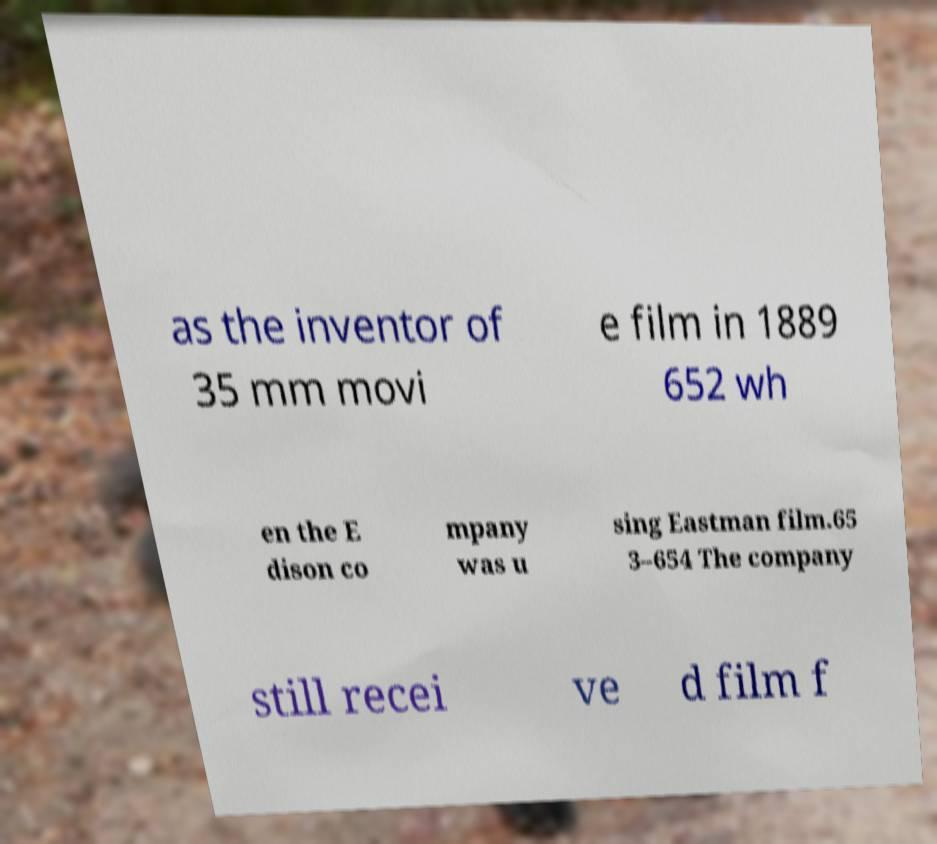There's text embedded in this image that I need extracted. Can you transcribe it verbatim? as the inventor of 35 mm movi e film in 1889 652 wh en the E dison co mpany was u sing Eastman film.65 3–654 The company still recei ve d film f 